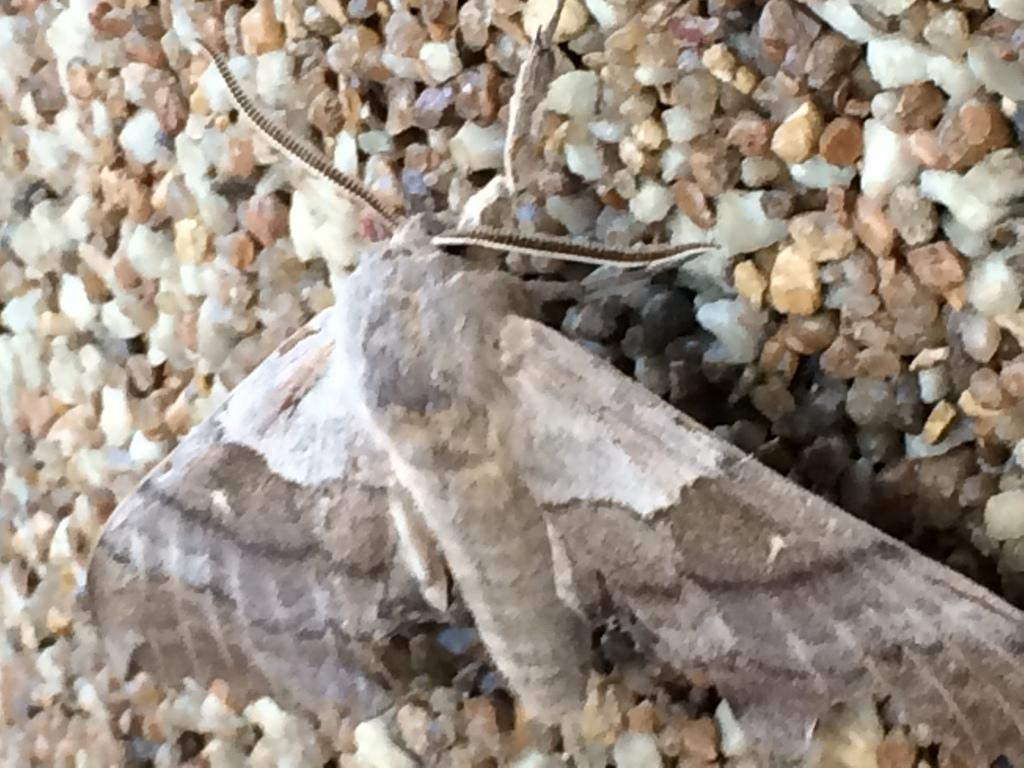What type of creature can be seen in the image? There is an insect in the image. What else is present in the image besides the insect? There are stones in the image. How many children are playing with the flesh in the image? There is no flesh or children present in the image. 